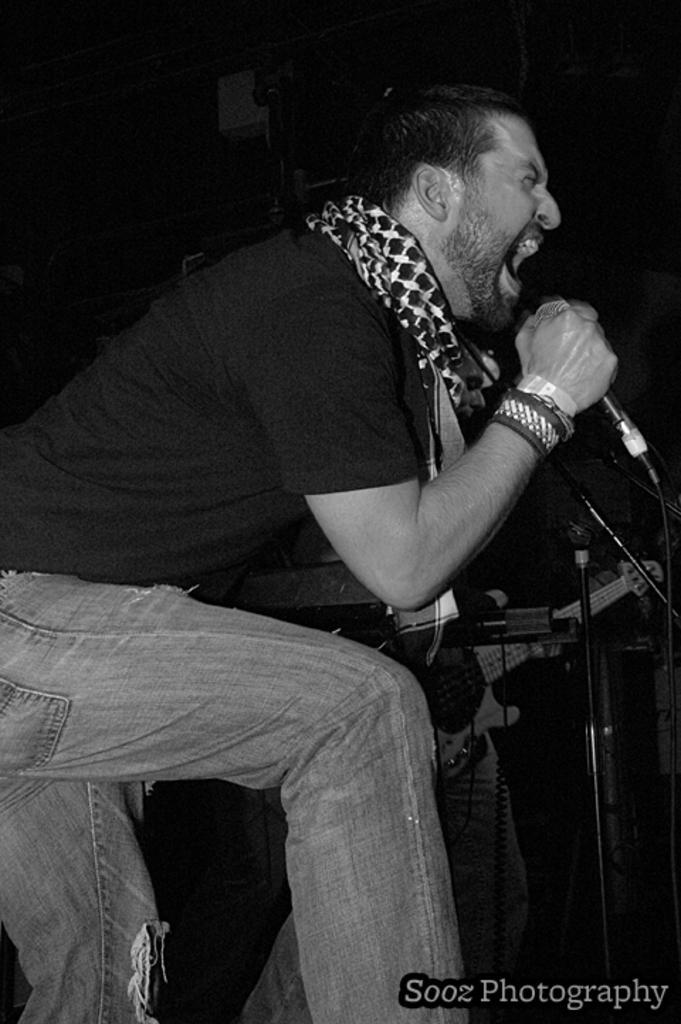Could you give a brief overview of what you see in this image? In this image there is one person who is standing and he is holding a mike it seems that he is singing, beside this person there is another person and one guitar is there. 